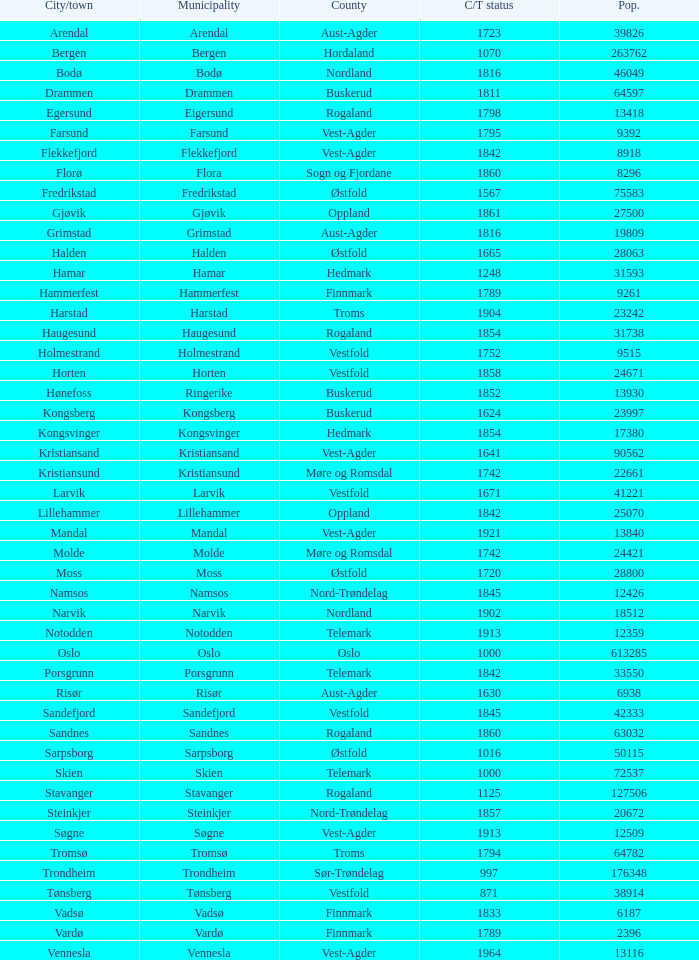Would you mind parsing the complete table? {'header': ['City/town', 'Municipality', 'County', 'C/T status', 'Pop.'], 'rows': [['Arendal', 'Arendal', 'Aust-Agder', '1723', '39826'], ['Bergen', 'Bergen', 'Hordaland', '1070', '263762'], ['Bodø', 'Bodø', 'Nordland', '1816', '46049'], ['Drammen', 'Drammen', 'Buskerud', '1811', '64597'], ['Egersund', 'Eigersund', 'Rogaland', '1798', '13418'], ['Farsund', 'Farsund', 'Vest-Agder', '1795', '9392'], ['Flekkefjord', 'Flekkefjord', 'Vest-Agder', '1842', '8918'], ['Florø', 'Flora', 'Sogn og Fjordane', '1860', '8296'], ['Fredrikstad', 'Fredrikstad', 'Østfold', '1567', '75583'], ['Gjøvik', 'Gjøvik', 'Oppland', '1861', '27500'], ['Grimstad', 'Grimstad', 'Aust-Agder', '1816', '19809'], ['Halden', 'Halden', 'Østfold', '1665', '28063'], ['Hamar', 'Hamar', 'Hedmark', '1248', '31593'], ['Hammerfest', 'Hammerfest', 'Finnmark', '1789', '9261'], ['Harstad', 'Harstad', 'Troms', '1904', '23242'], ['Haugesund', 'Haugesund', 'Rogaland', '1854', '31738'], ['Holmestrand', 'Holmestrand', 'Vestfold', '1752', '9515'], ['Horten', 'Horten', 'Vestfold', '1858', '24671'], ['Hønefoss', 'Ringerike', 'Buskerud', '1852', '13930'], ['Kongsberg', 'Kongsberg', 'Buskerud', '1624', '23997'], ['Kongsvinger', 'Kongsvinger', 'Hedmark', '1854', '17380'], ['Kristiansand', 'Kristiansand', 'Vest-Agder', '1641', '90562'], ['Kristiansund', 'Kristiansund', 'Møre og Romsdal', '1742', '22661'], ['Larvik', 'Larvik', 'Vestfold', '1671', '41221'], ['Lillehammer', 'Lillehammer', 'Oppland', '1842', '25070'], ['Mandal', 'Mandal', 'Vest-Agder', '1921', '13840'], ['Molde', 'Molde', 'Møre og Romsdal', '1742', '24421'], ['Moss', 'Moss', 'Østfold', '1720', '28800'], ['Namsos', 'Namsos', 'Nord-Trøndelag', '1845', '12426'], ['Narvik', 'Narvik', 'Nordland', '1902', '18512'], ['Notodden', 'Notodden', 'Telemark', '1913', '12359'], ['Oslo', 'Oslo', 'Oslo', '1000', '613285'], ['Porsgrunn', 'Porsgrunn', 'Telemark', '1842', '33550'], ['Risør', 'Risør', 'Aust-Agder', '1630', '6938'], ['Sandefjord', 'Sandefjord', 'Vestfold', '1845', '42333'], ['Sandnes', 'Sandnes', 'Rogaland', '1860', '63032'], ['Sarpsborg', 'Sarpsborg', 'Østfold', '1016', '50115'], ['Skien', 'Skien', 'Telemark', '1000', '72537'], ['Stavanger', 'Stavanger', 'Rogaland', '1125', '127506'], ['Steinkjer', 'Steinkjer', 'Nord-Trøndelag', '1857', '20672'], ['Søgne', 'Søgne', 'Vest-Agder', '1913', '12509'], ['Tromsø', 'Tromsø', 'Troms', '1794', '64782'], ['Trondheim', 'Trondheim', 'Sør-Trøndelag', '997', '176348'], ['Tønsberg', 'Tønsberg', 'Vestfold', '871', '38914'], ['Vadsø', 'Vadsø', 'Finnmark', '1833', '6187'], ['Vardø', 'Vardø', 'Finnmark', '1789', '2396'], ['Vennesla', 'Vennesla', 'Vest-Agder', '1964', '13116']]} Which municipalities located in the county of Finnmark have populations bigger than 6187.0? Hammerfest. 